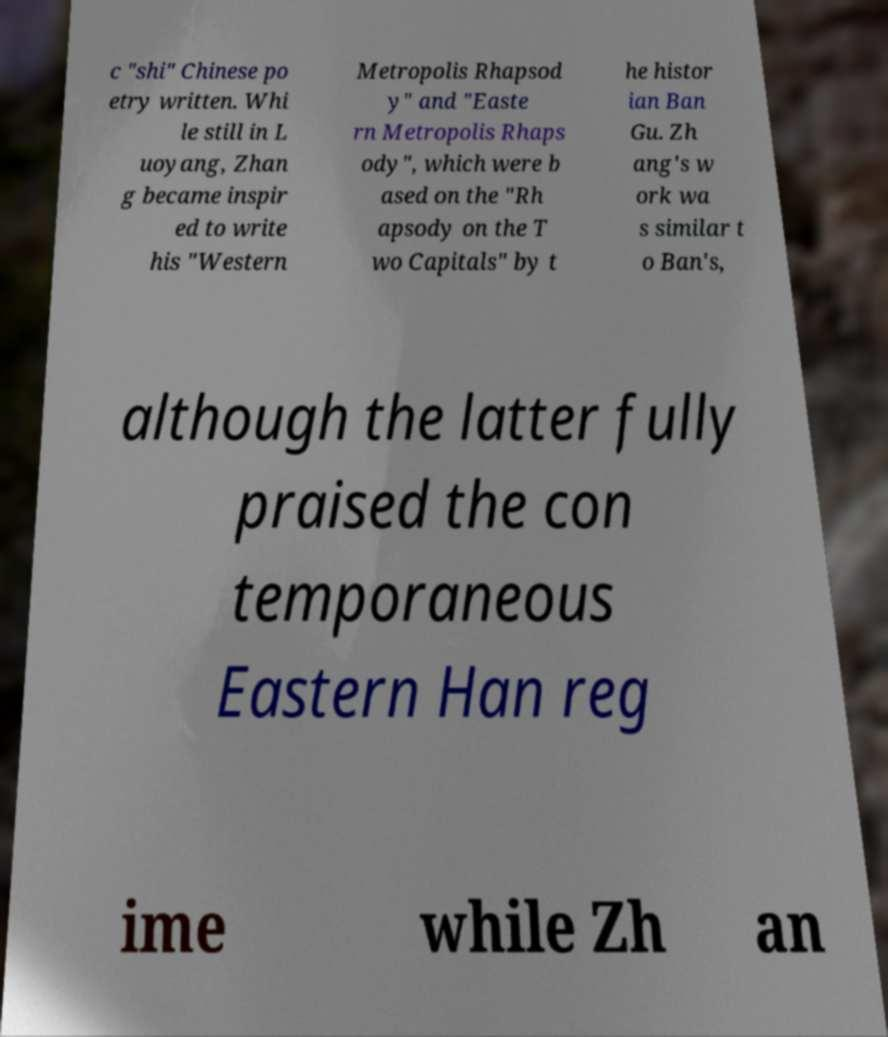I need the written content from this picture converted into text. Can you do that? c "shi" Chinese po etry written. Whi le still in L uoyang, Zhan g became inspir ed to write his "Western Metropolis Rhapsod y" and "Easte rn Metropolis Rhaps ody", which were b ased on the "Rh apsody on the T wo Capitals" by t he histor ian Ban Gu. Zh ang's w ork wa s similar t o Ban's, although the latter fully praised the con temporaneous Eastern Han reg ime while Zh an 